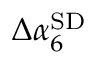Convert formula to latex. <formula><loc_0><loc_0><loc_500><loc_500>\Delta \alpha _ { 6 } ^ { S D }</formula> 